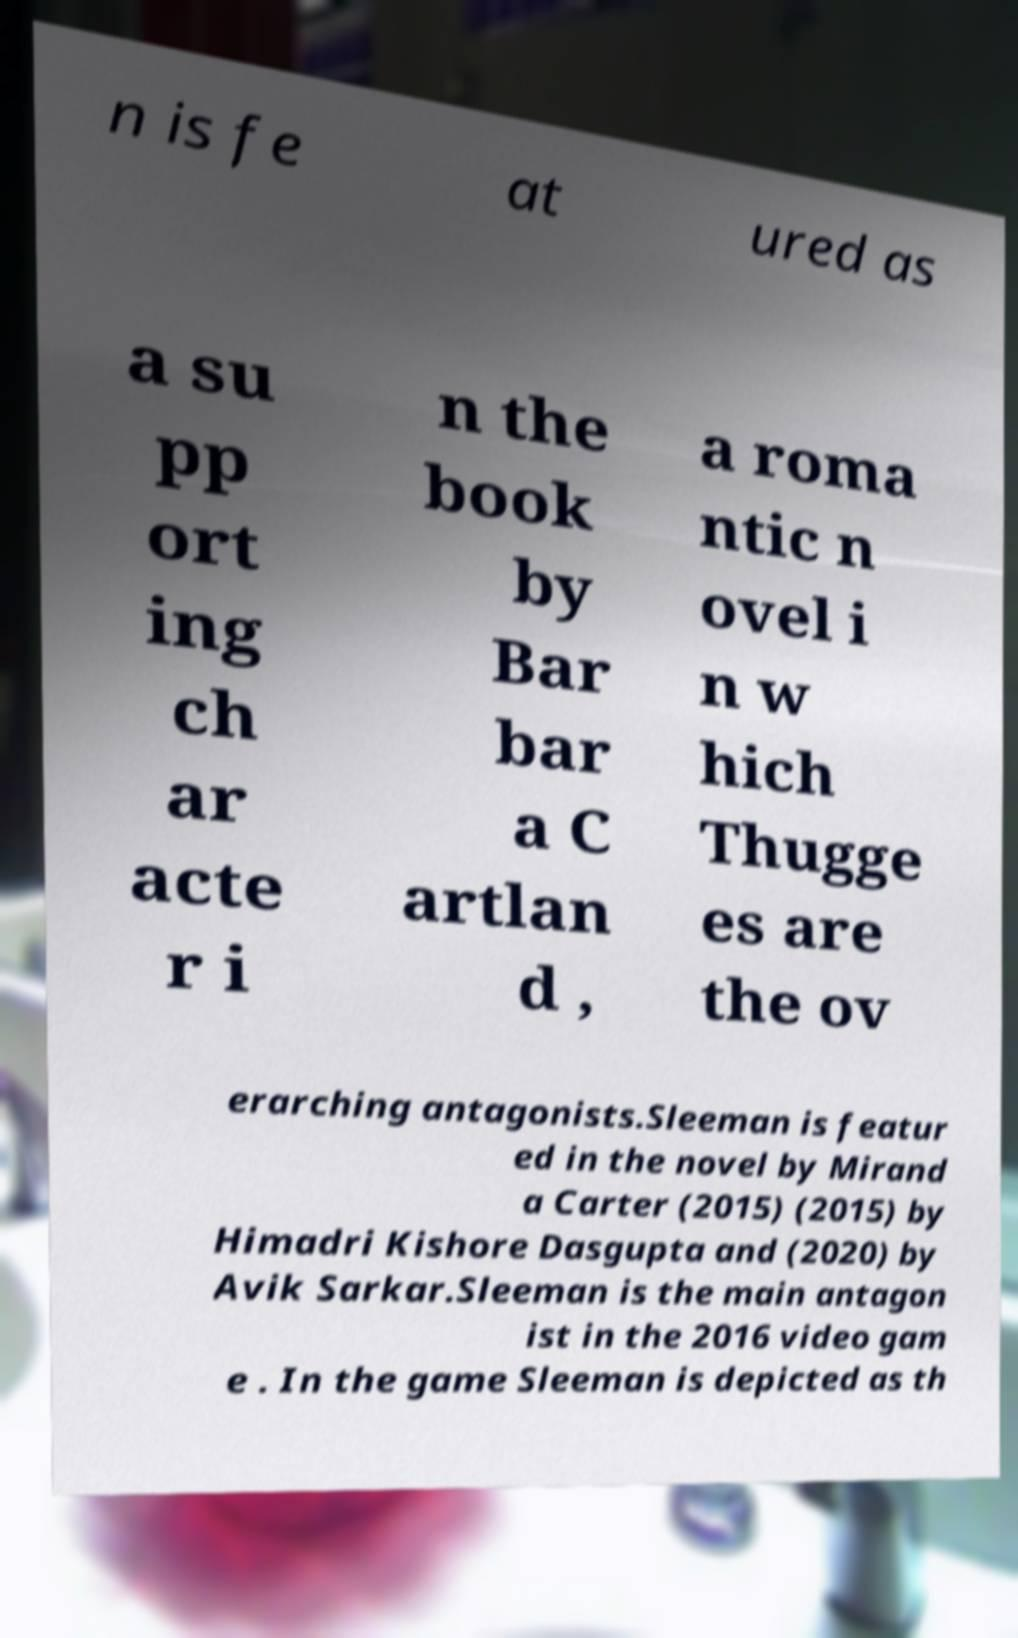There's text embedded in this image that I need extracted. Can you transcribe it verbatim? n is fe at ured as a su pp ort ing ch ar acte r i n the book by Bar bar a C artlan d , a roma ntic n ovel i n w hich Thugge es are the ov erarching antagonists.Sleeman is featur ed in the novel by Mirand a Carter (2015) (2015) by Himadri Kishore Dasgupta and (2020) by Avik Sarkar.Sleeman is the main antagon ist in the 2016 video gam e . In the game Sleeman is depicted as th 